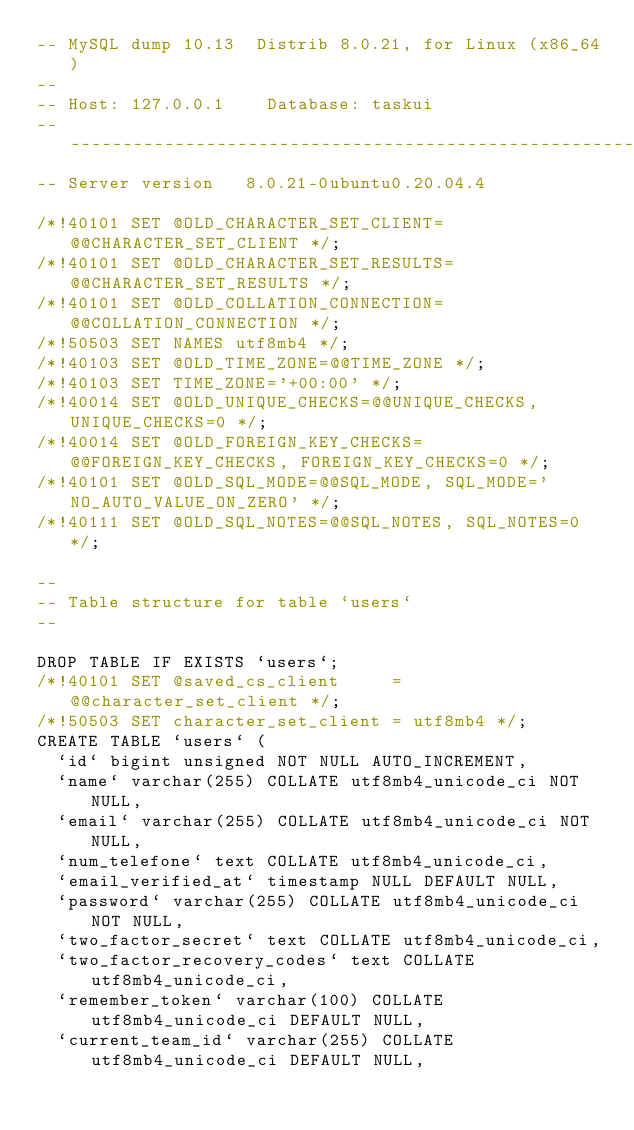Convert code to text. <code><loc_0><loc_0><loc_500><loc_500><_SQL_>-- MySQL dump 10.13  Distrib 8.0.21, for Linux (x86_64)
--
-- Host: 127.0.0.1    Database: taskui
-- ------------------------------------------------------
-- Server version	8.0.21-0ubuntu0.20.04.4

/*!40101 SET @OLD_CHARACTER_SET_CLIENT=@@CHARACTER_SET_CLIENT */;
/*!40101 SET @OLD_CHARACTER_SET_RESULTS=@@CHARACTER_SET_RESULTS */;
/*!40101 SET @OLD_COLLATION_CONNECTION=@@COLLATION_CONNECTION */;
/*!50503 SET NAMES utf8mb4 */;
/*!40103 SET @OLD_TIME_ZONE=@@TIME_ZONE */;
/*!40103 SET TIME_ZONE='+00:00' */;
/*!40014 SET @OLD_UNIQUE_CHECKS=@@UNIQUE_CHECKS, UNIQUE_CHECKS=0 */;
/*!40014 SET @OLD_FOREIGN_KEY_CHECKS=@@FOREIGN_KEY_CHECKS, FOREIGN_KEY_CHECKS=0 */;
/*!40101 SET @OLD_SQL_MODE=@@SQL_MODE, SQL_MODE='NO_AUTO_VALUE_ON_ZERO' */;
/*!40111 SET @OLD_SQL_NOTES=@@SQL_NOTES, SQL_NOTES=0 */;

--
-- Table structure for table `users`
--

DROP TABLE IF EXISTS `users`;
/*!40101 SET @saved_cs_client     = @@character_set_client */;
/*!50503 SET character_set_client = utf8mb4 */;
CREATE TABLE `users` (
  `id` bigint unsigned NOT NULL AUTO_INCREMENT,
  `name` varchar(255) COLLATE utf8mb4_unicode_ci NOT NULL,
  `email` varchar(255) COLLATE utf8mb4_unicode_ci NOT NULL,
  `num_telefone` text COLLATE utf8mb4_unicode_ci,
  `email_verified_at` timestamp NULL DEFAULT NULL,
  `password` varchar(255) COLLATE utf8mb4_unicode_ci NOT NULL,
  `two_factor_secret` text COLLATE utf8mb4_unicode_ci,
  `two_factor_recovery_codes` text COLLATE utf8mb4_unicode_ci,
  `remember_token` varchar(100) COLLATE utf8mb4_unicode_ci DEFAULT NULL,
  `current_team_id` varchar(255) COLLATE utf8mb4_unicode_ci DEFAULT NULL,</code> 